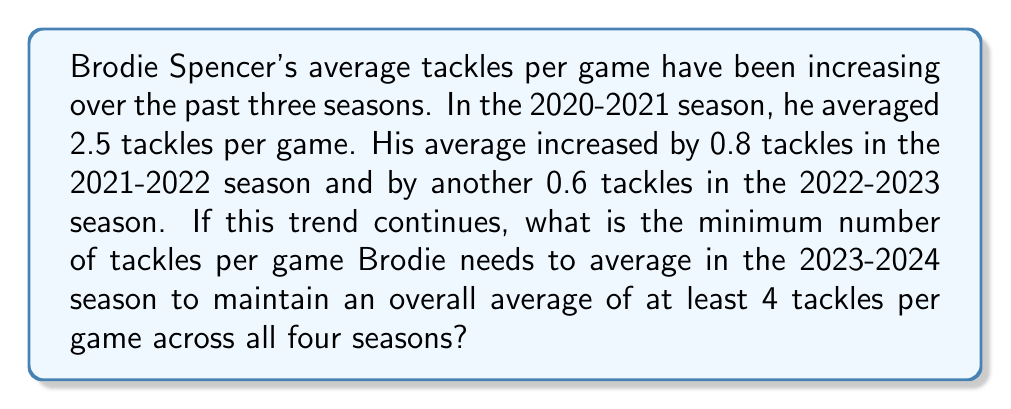Teach me how to tackle this problem. Let's approach this step-by-step:

1) First, let's calculate Brodie's average tackles for each season:
   2020-2021: 2.5
   2021-2022: 2.5 + 0.8 = 3.3
   2022-2023: 3.3 + 0.6 = 3.9

2) Let $x$ be the average tackles per game in the 2023-2024 season.

3) For the overall average to be at least 4, we can set up the following inequality:

   $$ \frac{2.5 + 3.3 + 3.9 + x}{4} \geq 4 $$

4) Simplify the left side:

   $$ \frac{9.7 + x}{4} \geq 4 $$

5) Multiply both sides by 4:

   $$ 9.7 + x \geq 16 $$

6) Subtract 9.7 from both sides:

   $$ x \geq 6.3 $$

7) Since we're looking for the minimum number of tackles, and tackles are typically counted as whole numbers, we need to round up to the nearest integer.
Answer: 7 tackles per game 